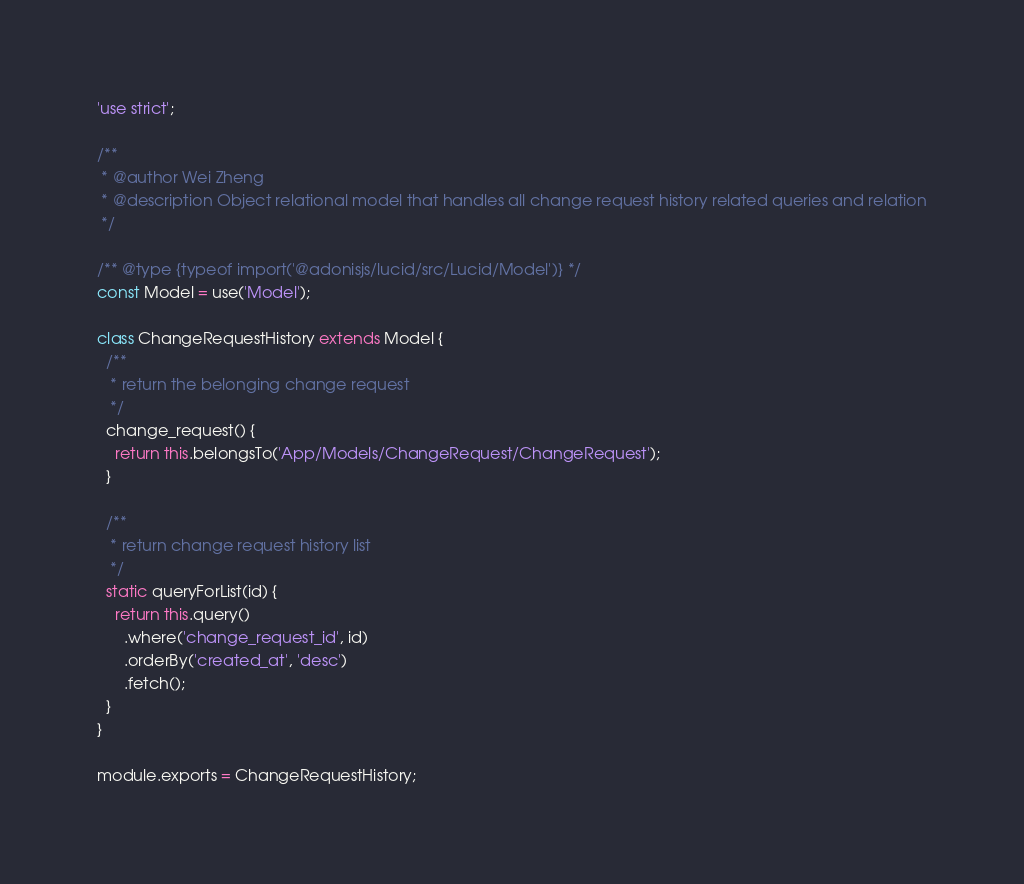<code> <loc_0><loc_0><loc_500><loc_500><_JavaScript_>'use strict';

/**
 * @author Wei Zheng
 * @description Object relational model that handles all change request history related queries and relation
 */

/** @type {typeof import('@adonisjs/lucid/src/Lucid/Model')} */
const Model = use('Model');

class ChangeRequestHistory extends Model {
  /**
   * return the belonging change request
   */
  change_request() {
    return this.belongsTo('App/Models/ChangeRequest/ChangeRequest');
  }

  /**
   * return change request history list
   */
  static queryForList(id) {
    return this.query()
      .where('change_request_id', id)
      .orderBy('created_at', 'desc')
      .fetch();
  }
}

module.exports = ChangeRequestHistory;
</code> 